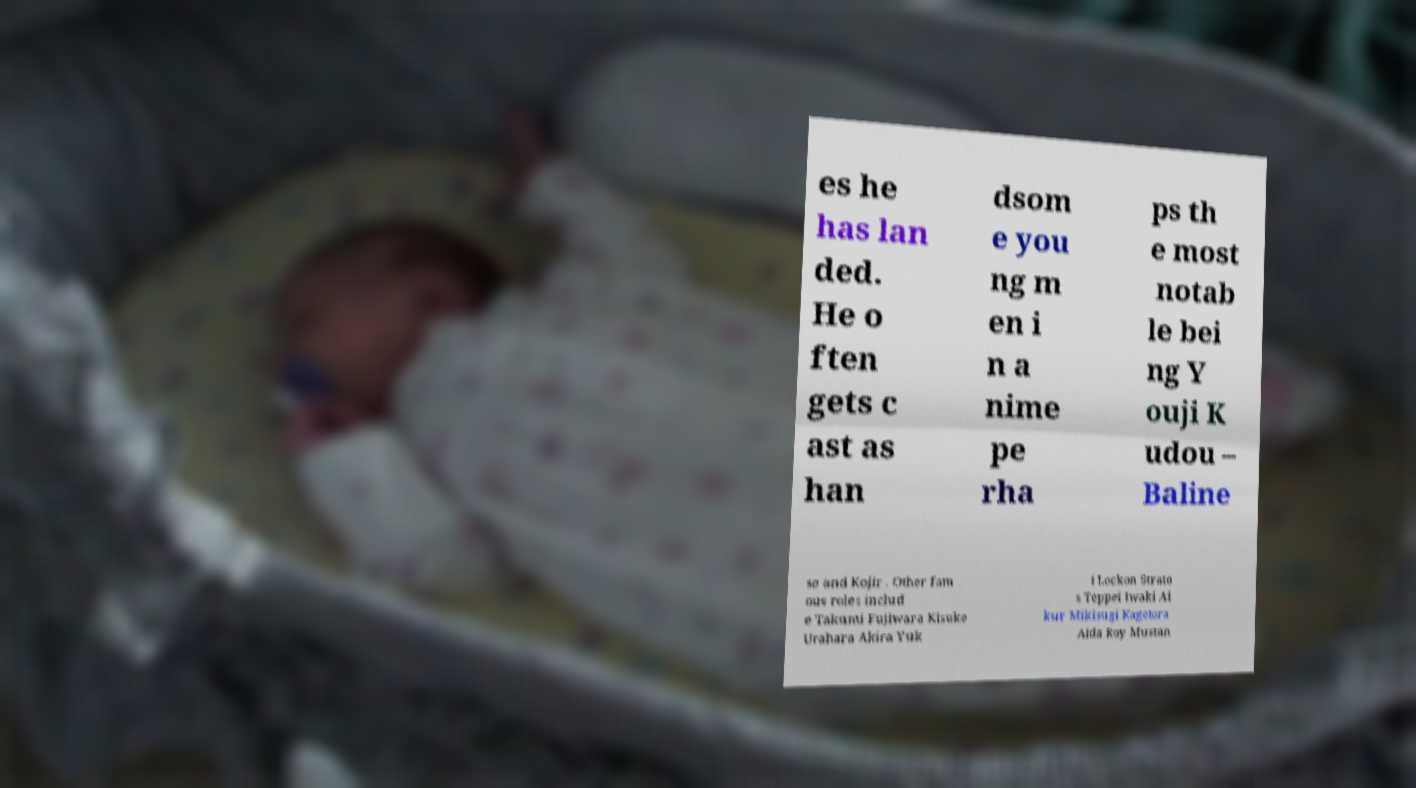Can you read and provide the text displayed in the image?This photo seems to have some interesting text. Can you extract and type it out for me? es he has lan ded. He o ften gets c ast as han dsom e you ng m en i n a nime pe rha ps th e most notab le bei ng Y ouji K udou – Baline se and Kojir . Other fam ous roles includ e Takumi Fujiwara Kisuke Urahara Akira Yuk i Lockon Strato s Teppei Iwaki Ai kur Mikisugi Kagetora Aida Roy Mustan 